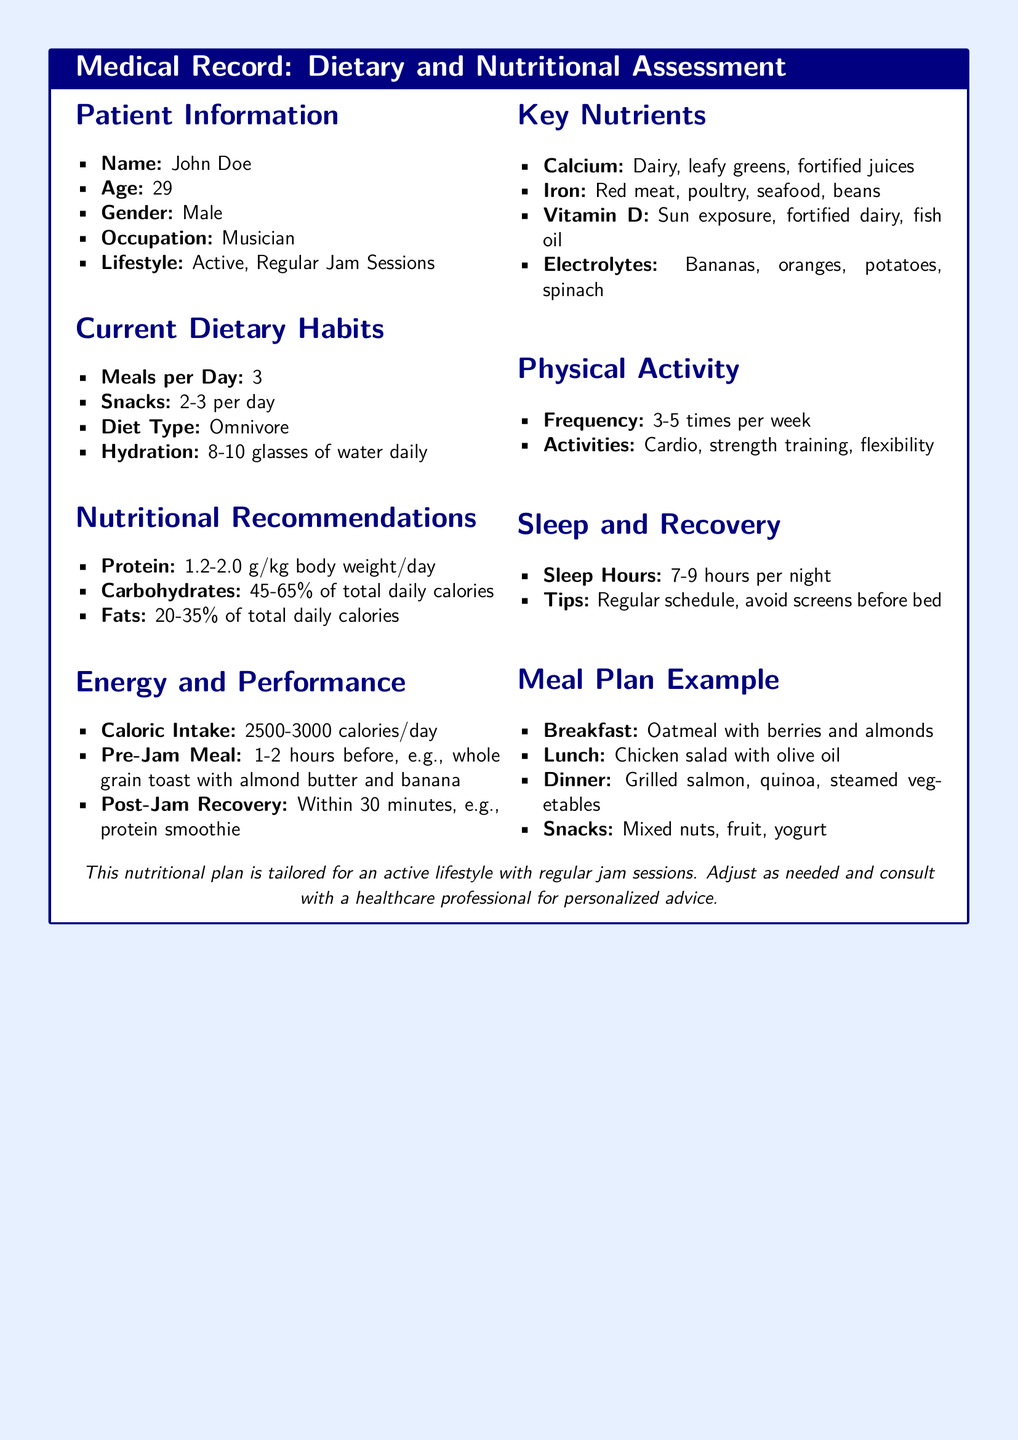What is the patient's name? The patient's name is provided in the Patient Information section.
Answer: John Doe How many meals does the patient consume per day? This information is located in the Current Dietary Habits section.
Answer: 3 What is the recommended protein intake for the patient? The recommended protein intake is specified in the Nutritional Recommendations section.
Answer: 1.2-2.0 g/kg body weight/day What type of diet does the patient follow? This detail is mentioned in the Current Dietary Habits section.
Answer: Omnivore What is the caloric intake range recommended for the patient? The caloric intake range is given in the Energy and Performance section.
Answer: 2500-3000 calories/day What should the patient eat before a jam session? This is described in the Energy and Performance section under Pre-Jam Meal.
Answer: Whole grain toast with almond butter and banana How often does the patient engage in physical activity? This frequency is mentioned in the Physical Activity section.
Answer: 3-5 times per week How many hours of sleep is recommended for the patient? The recommended sleep hours are indicated in the Sleep and Recovery section.
Answer: 7-9 hours per night What is an example of a post-jam recovery meal? The example is provided in the Energy and Performance section under Post-Jam Recovery.
Answer: Protein smoothie 